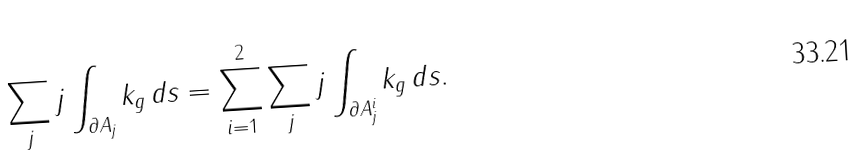<formula> <loc_0><loc_0><loc_500><loc_500>\sum _ { j } j \int _ { \partial A _ { j } } k _ { g } \, d s = \sum _ { i = 1 } ^ { 2 } \sum _ { j } j \int _ { \partial A ^ { i } _ { j } } k _ { g } \, d s .</formula> 